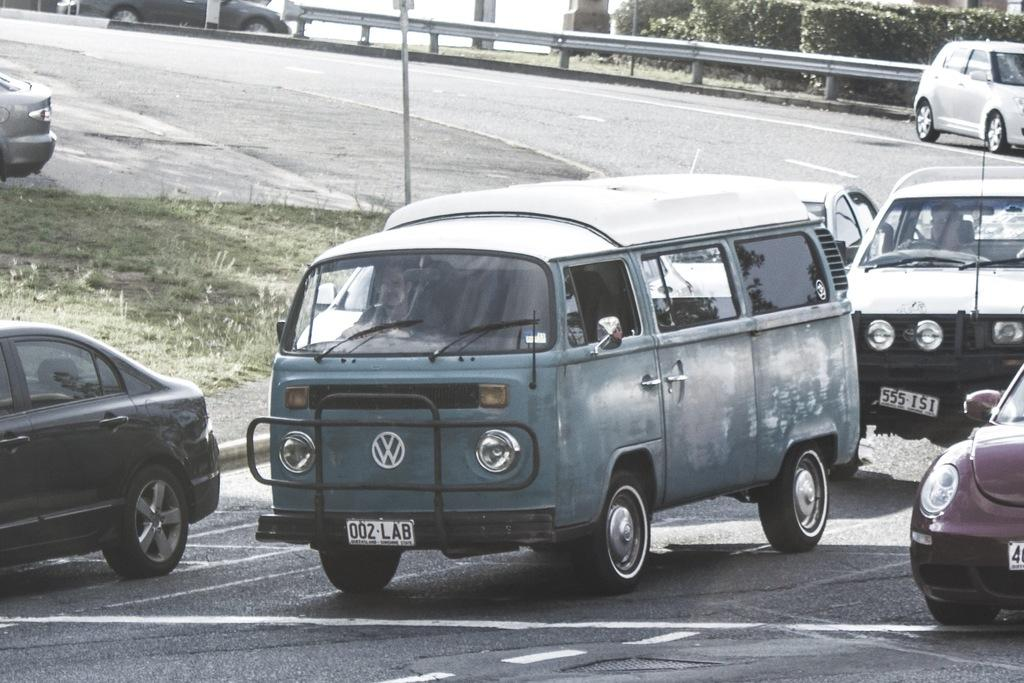What can be seen on the road in the image? There are vehicles on the road in the image. What type of vegetation is visible in the image? There is grass visible in the image. What can be seen in the background of the image? There are plants in the background of the image. What letters are written on the brick wall in the image? There is no brick wall present in the image, and therefore no letters can be observed. What month is depicted in the image? The image does not show any specific month or time of year. 